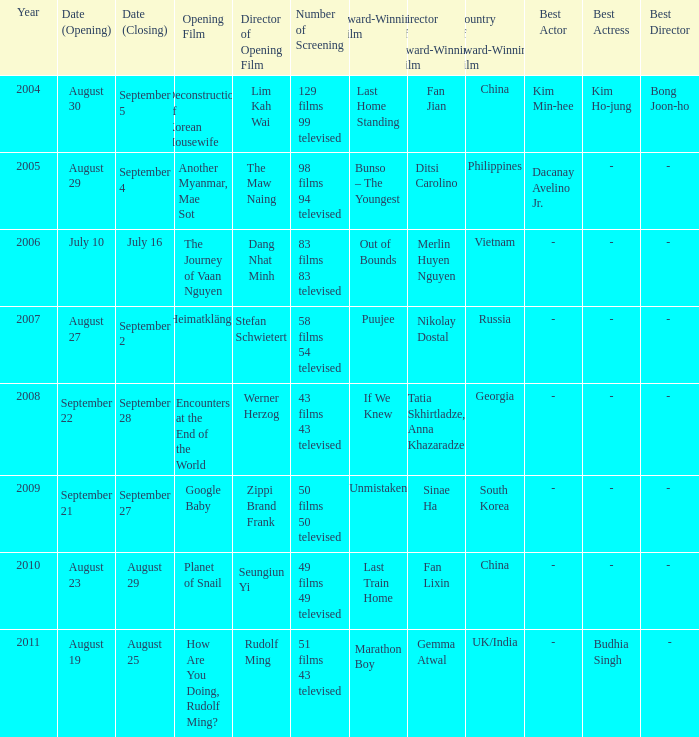How many screenings were held for the opening film, the journey of vaan nguyen? 1.0. 